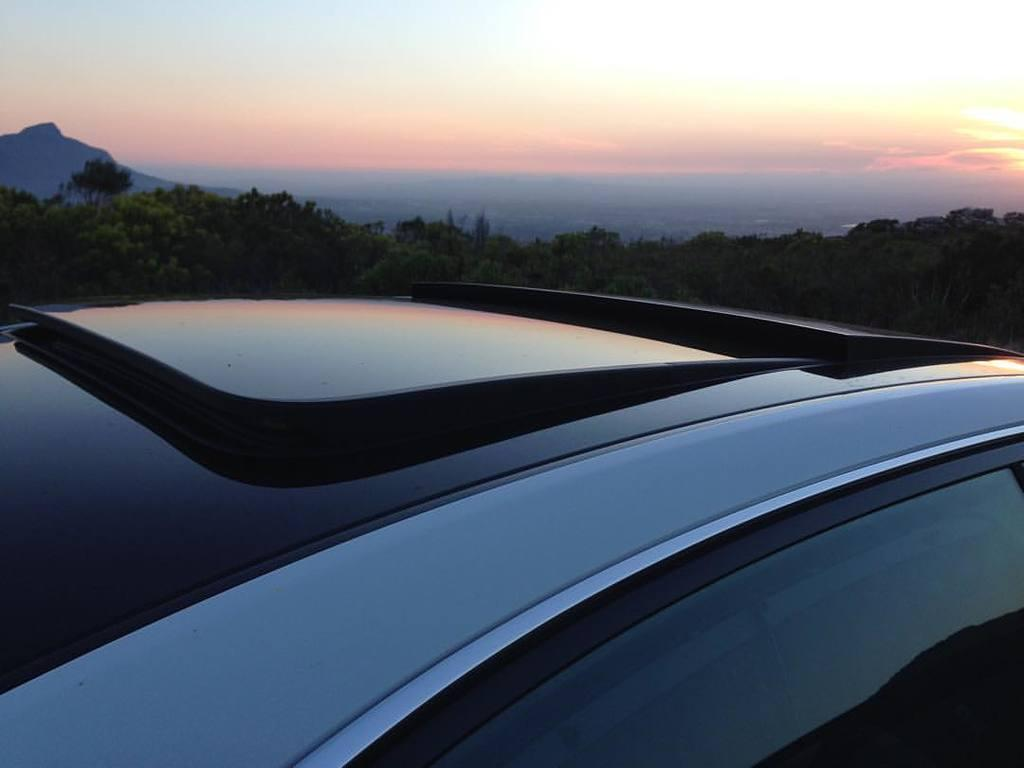What is the main subject of the image? There is a car in the image. What can be seen in the background of the image? There are trees and a mountain in the background of the image. What is visible above the trees and mountain? The sky is visible in the background of the image. What type of creature can be seen stamping its feet on the car in the image? There is no creature present in the image, and the car is not being stamped on. 